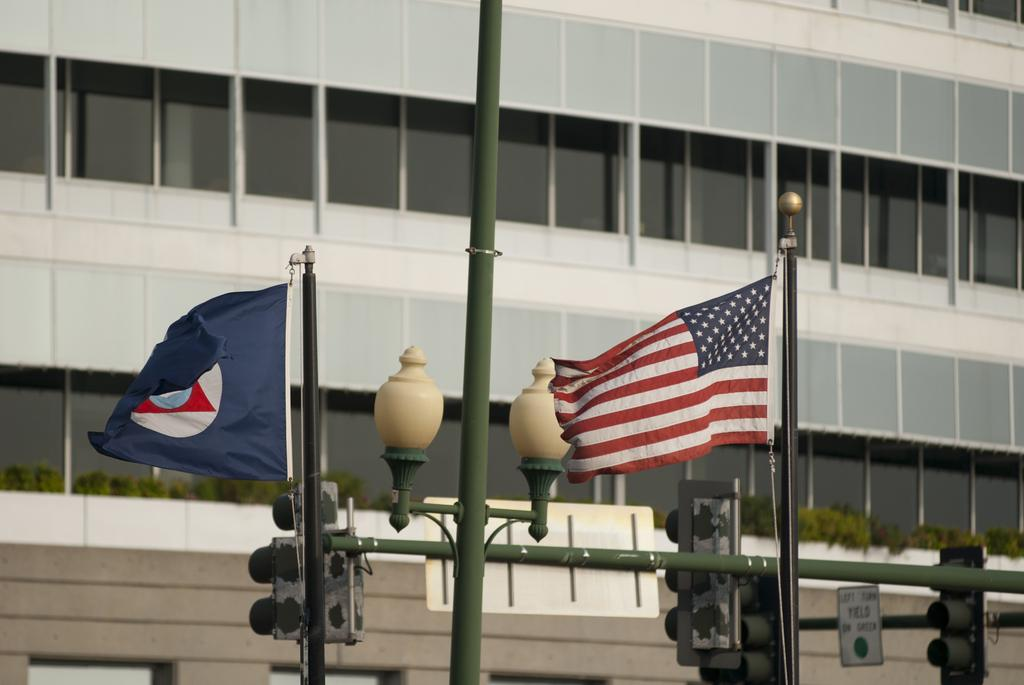What can be seen attached to poles in the image? There are two flags attached to poles in the image. What type of light is visible in the image? There is a street light in the image. What other type of light is attached to the poles in the image? There are traffic lights attached to the poles in the image. What can be seen in the background of the image? There is a building with windows in the background of the image. Can you tell me how many pickles are on the slope in the image? There are no pickles or slopes present in the image. What type of riddle can be solved by looking at the flags in the image? There is no riddle associated with the flags in the image. 